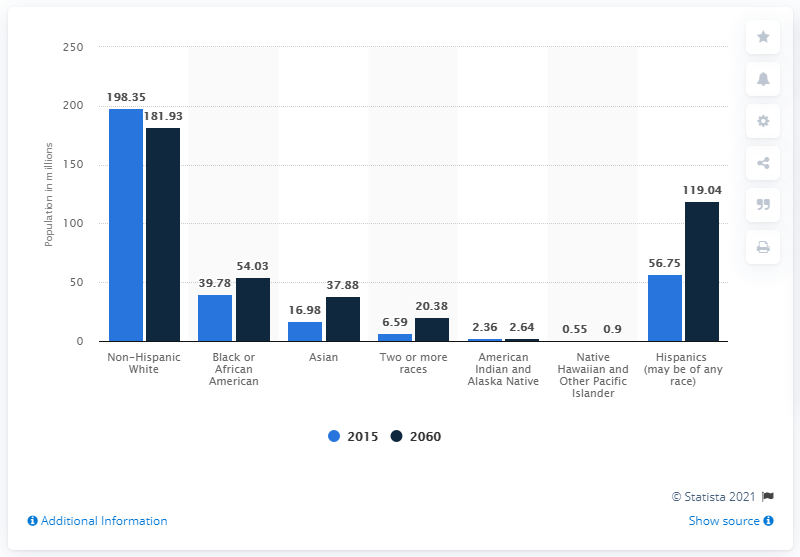Draw attention to some important aspects in this diagram. By 2060, it is projected that there will be 119.04 Hispanics living in the United States. 